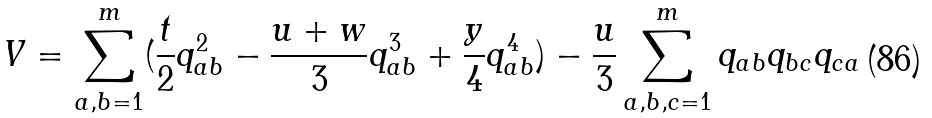<formula> <loc_0><loc_0><loc_500><loc_500>V = \sum _ { a , b = 1 } ^ { m } ( \frac { t } { 2 } q _ { a b } ^ { 2 } - \frac { u + w } { 3 } q _ { a b } ^ { 3 } + \frac { y } { 4 } q _ { a b } ^ { 4 } ) - \frac { u } { 3 } \sum _ { a , b , c = 1 } ^ { m } q _ { a b } q _ { b c } q _ { c a }</formula> 